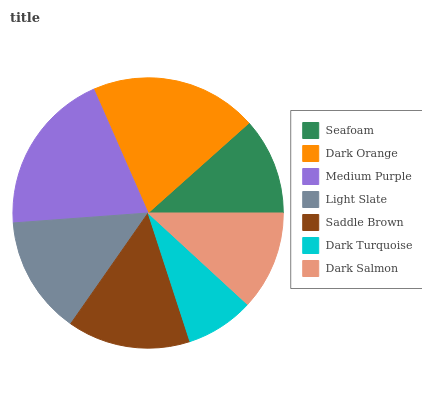Is Dark Turquoise the minimum?
Answer yes or no. Yes. Is Dark Orange the maximum?
Answer yes or no. Yes. Is Medium Purple the minimum?
Answer yes or no. No. Is Medium Purple the maximum?
Answer yes or no. No. Is Dark Orange greater than Medium Purple?
Answer yes or no. Yes. Is Medium Purple less than Dark Orange?
Answer yes or no. Yes. Is Medium Purple greater than Dark Orange?
Answer yes or no. No. Is Dark Orange less than Medium Purple?
Answer yes or no. No. Is Light Slate the high median?
Answer yes or no. Yes. Is Light Slate the low median?
Answer yes or no. Yes. Is Dark Orange the high median?
Answer yes or no. No. Is Medium Purple the low median?
Answer yes or no. No. 